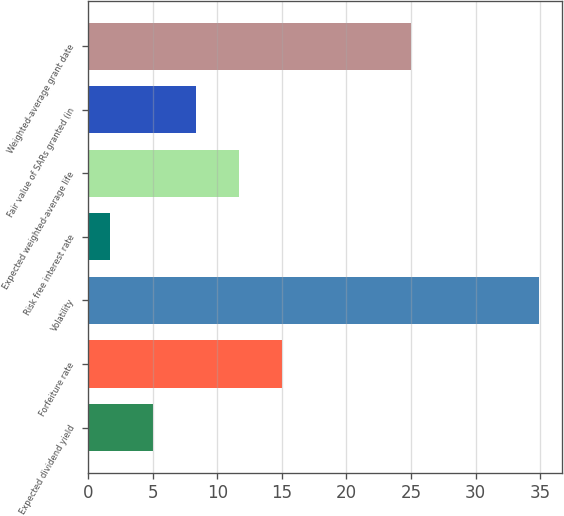<chart> <loc_0><loc_0><loc_500><loc_500><bar_chart><fcel>Expected dividend yield<fcel>Forfeiture rate<fcel>Volatility<fcel>Risk free interest rate<fcel>Expected weighted-average life<fcel>Fair value of SARs granted (in<fcel>Weighted-average grant date<nl><fcel>5.05<fcel>15.01<fcel>34.92<fcel>1.73<fcel>11.69<fcel>8.37<fcel>24.98<nl></chart> 